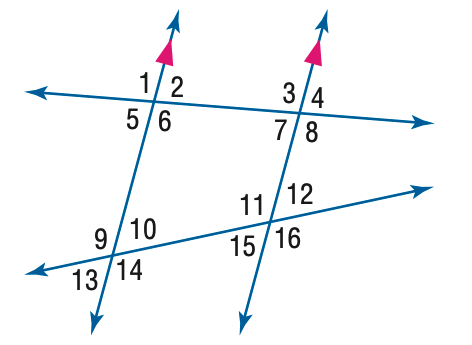Answer the mathemtical geometry problem and directly provide the correct option letter.
Question: In the figure, m \angle 2 = 110 and m \angle 12 = 55. Find the measure of \angle 2.
Choices: A: 55 B: 70 C: 80 D: 110 B 